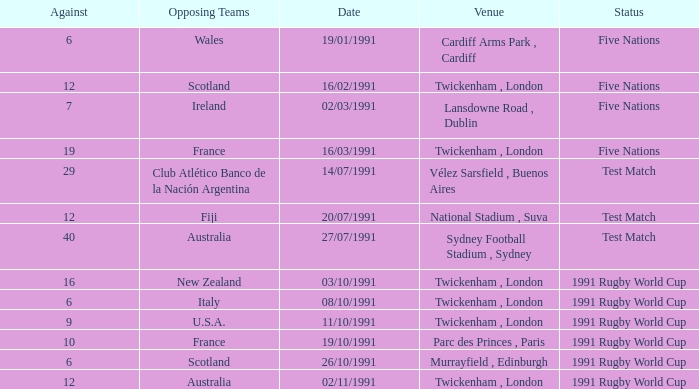What is Opposing Teams, when Date is "11/10/1991"? U.S.A. 